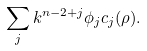<formula> <loc_0><loc_0><loc_500><loc_500>\sum _ { j } k ^ { n - 2 + j } \phi _ { j } c _ { j } ( \rho ) .</formula> 